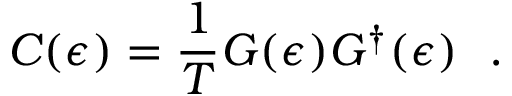Convert formula to latex. <formula><loc_0><loc_0><loc_500><loc_500>C ( \epsilon ) = \frac { 1 } { T } G ( \epsilon ) G ^ { \dagger } ( \epsilon ) .</formula> 